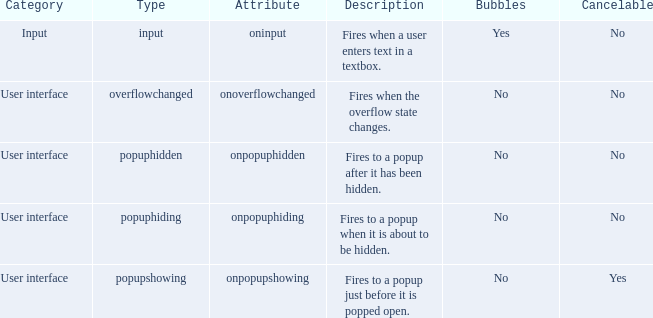What's the attribute with cancelable being yes Onpopupshowing. 